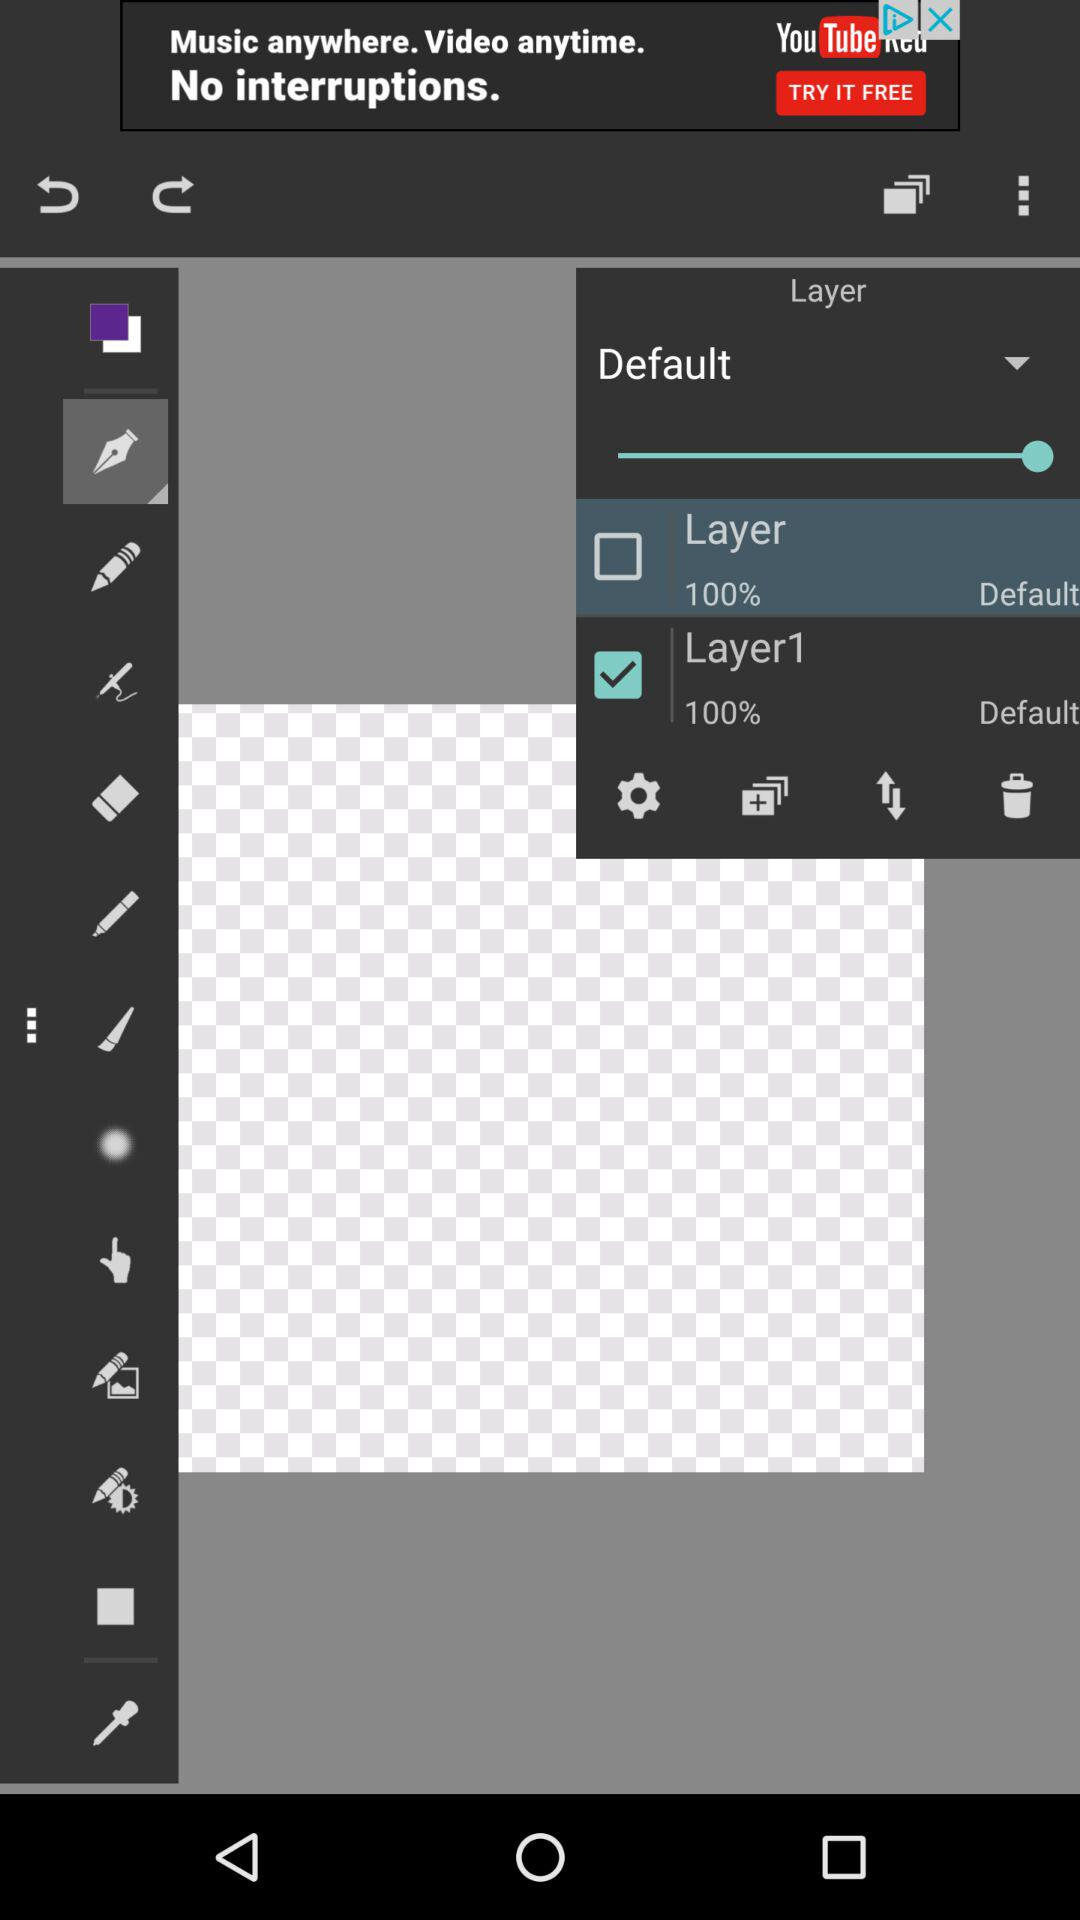What is the given percentage of "Layer"? The given percentage of "Layer" is 100. 